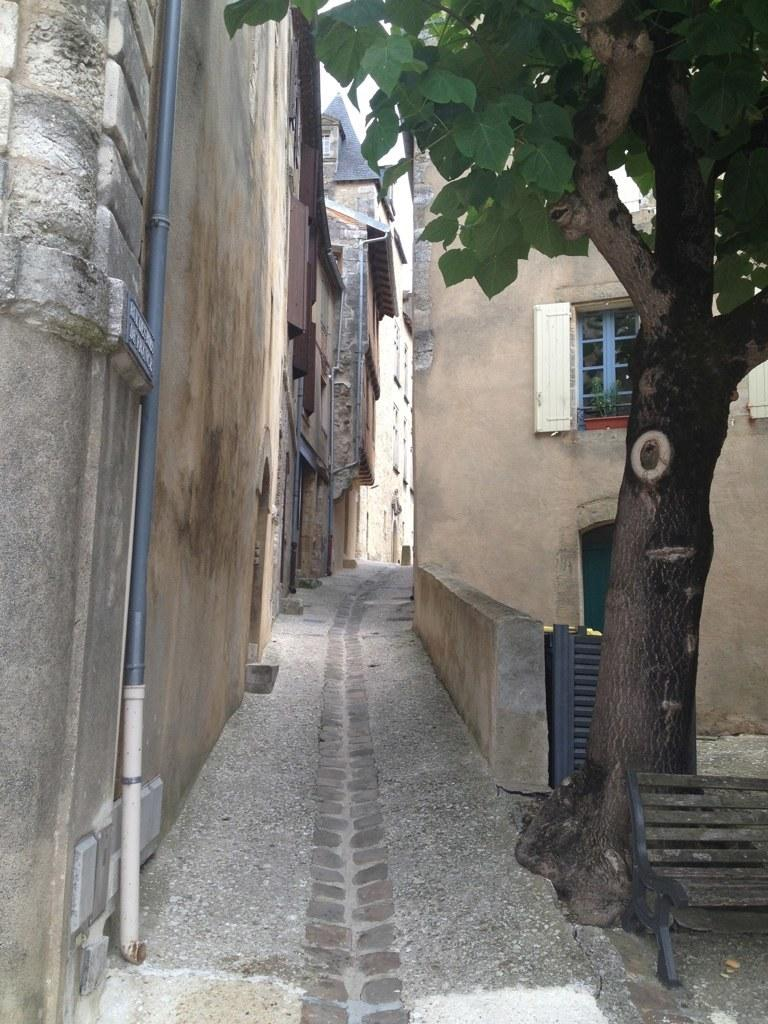What type of pathway is visible in the image? There is a small lane in the image. What can be observed about the buildings on both sides of the lane? The buildings on both sides of the lane are brown in color. What is located on the left side of the lane? There is a pipe on the left side of the lane. What is present on the right side of the lane? There is a tree trunk and a wooden bench on the right side of the lane. Who is the manager of the kittens in the image? There are no kittens present in the image, so there is no manager for them. 